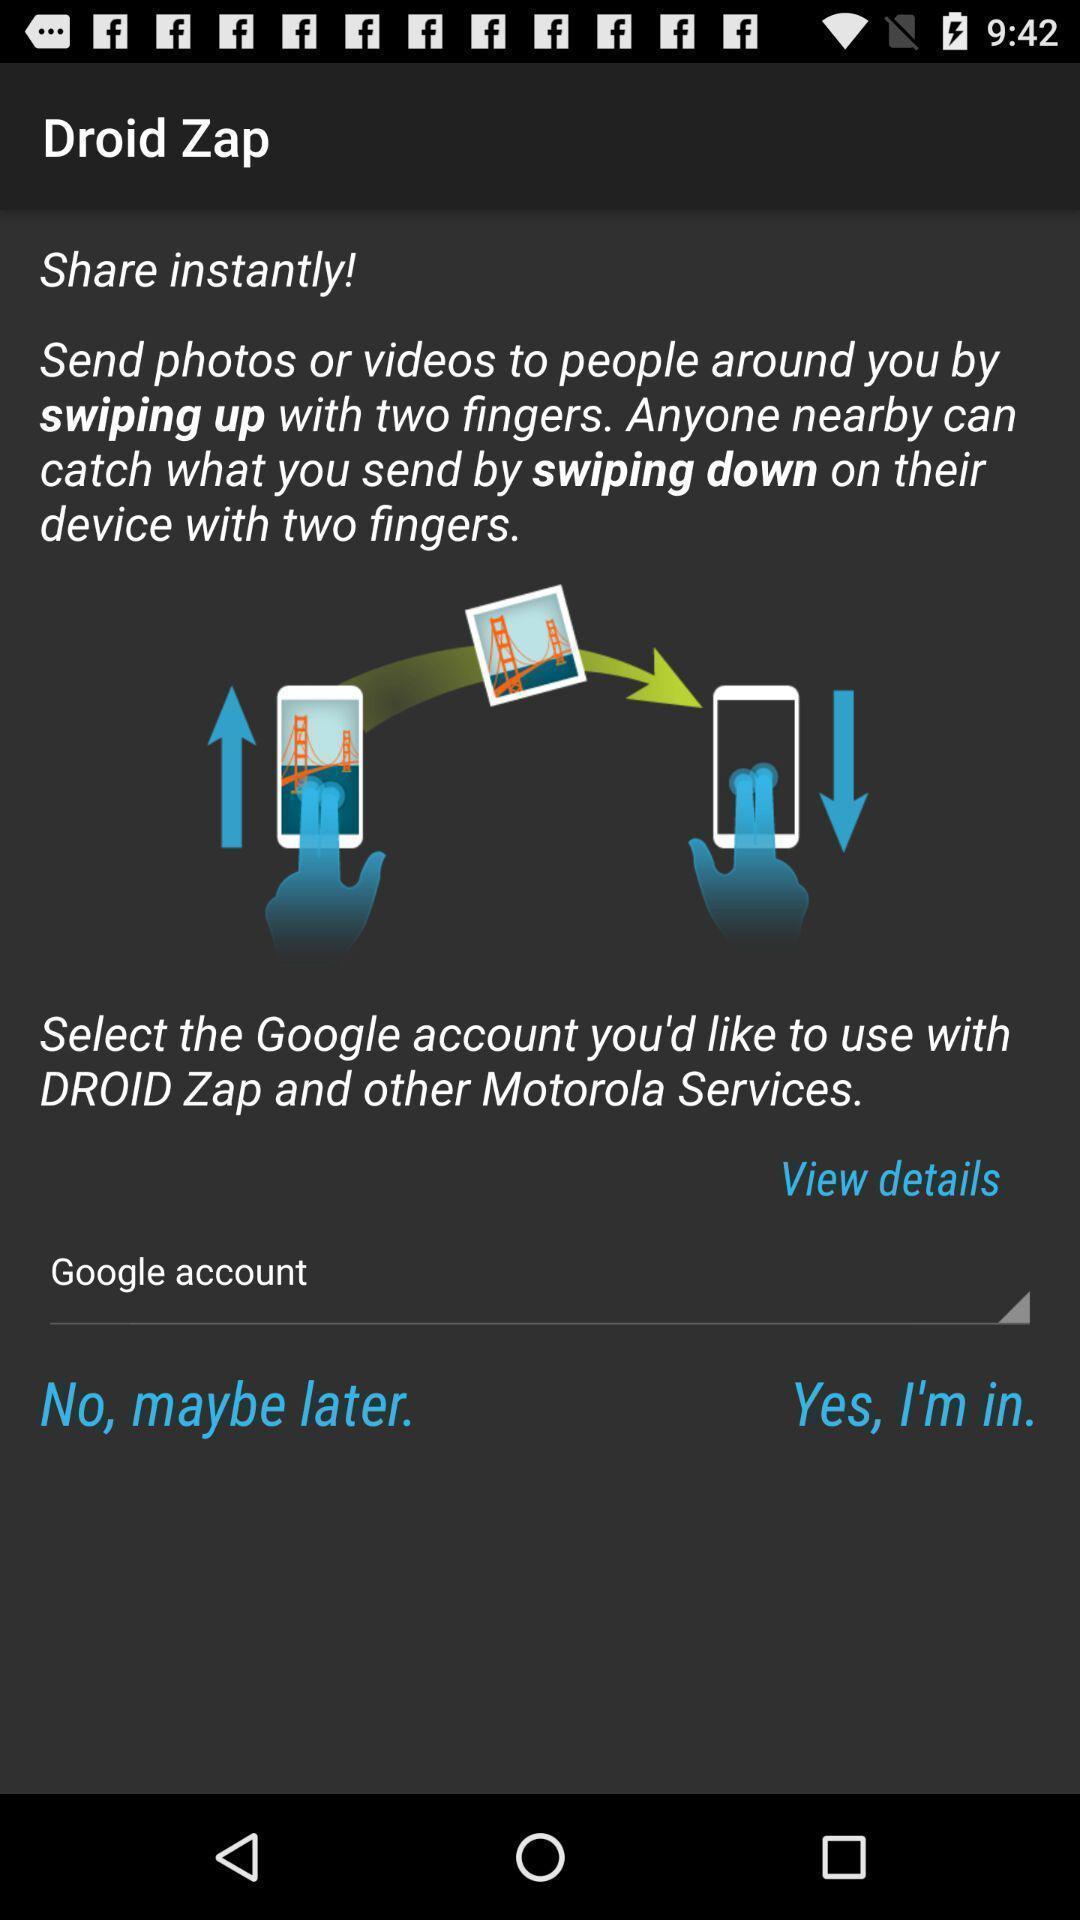Summarize the information in this screenshot. Screen showing page. 